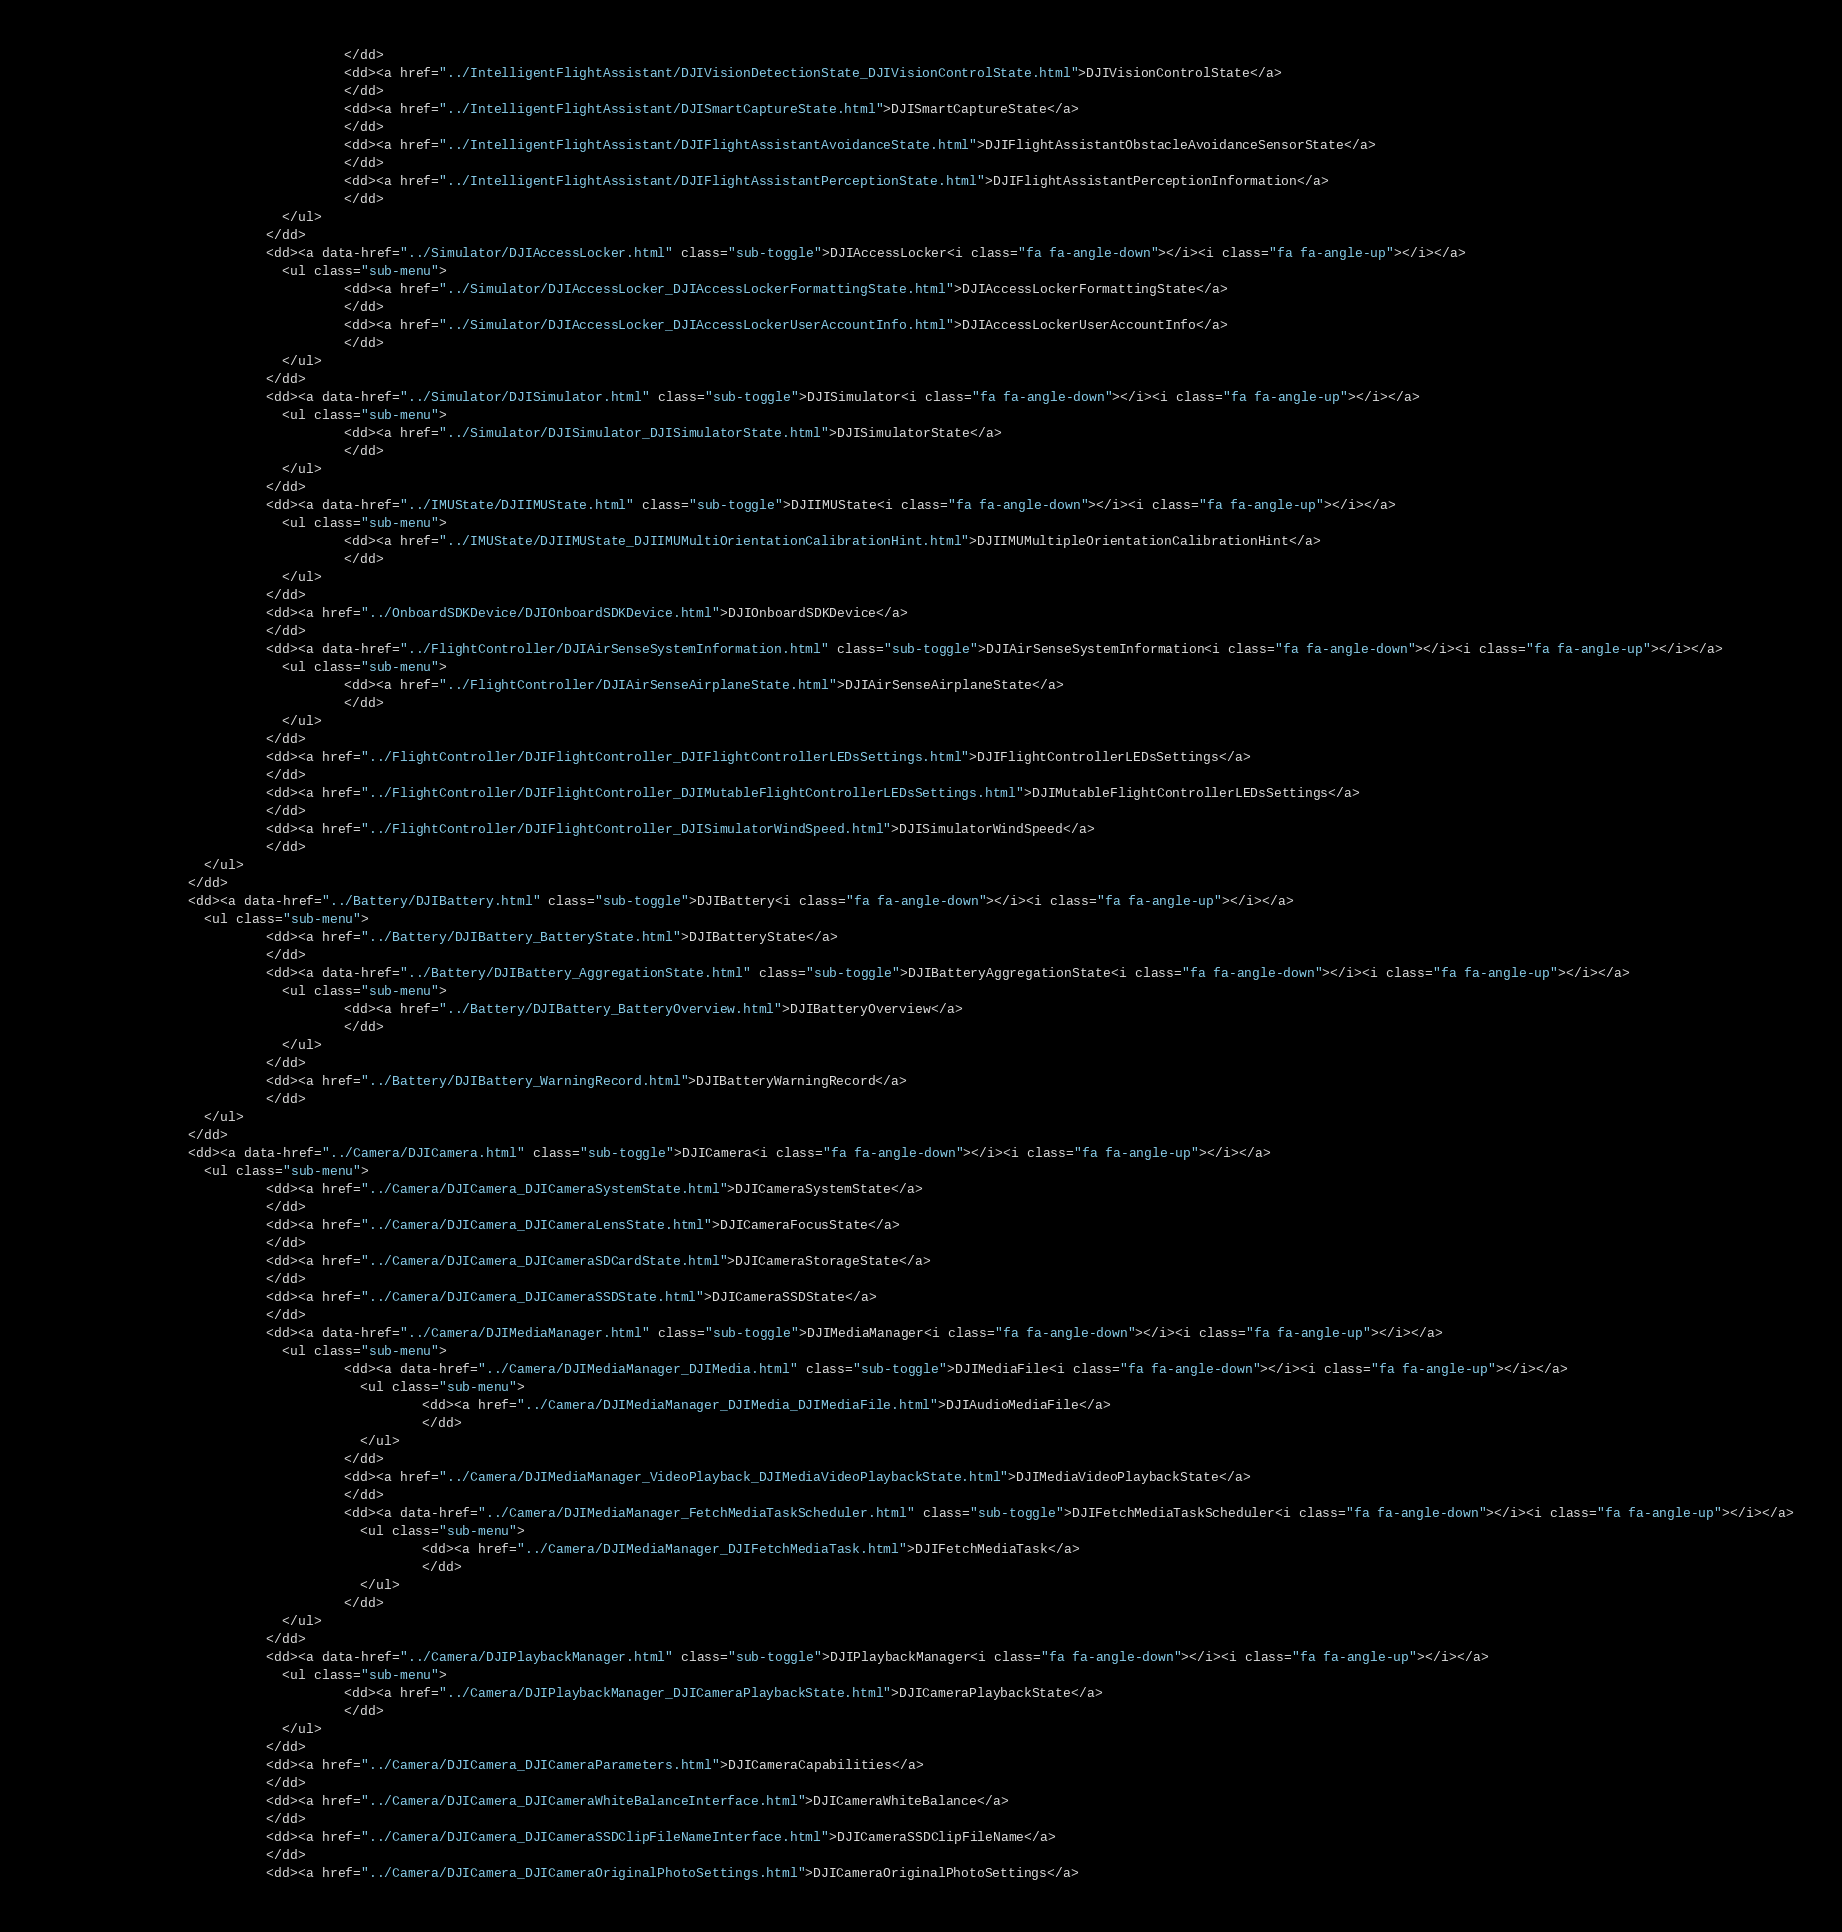<code> <loc_0><loc_0><loc_500><loc_500><_HTML_>                                      </dd>
                                      <dd><a href="../IntelligentFlightAssistant/DJIVisionDetectionState_DJIVisionControlState.html">DJIVisionControlState</a>
                                      </dd>
                                      <dd><a href="../IntelligentFlightAssistant/DJISmartCaptureState.html">DJISmartCaptureState</a>
                                      </dd>
                                      <dd><a href="../IntelligentFlightAssistant/DJIFlightAssistantAvoidanceState.html">DJIFlightAssistantObstacleAvoidanceSensorState</a>
                                      </dd>
                                      <dd><a href="../IntelligentFlightAssistant/DJIFlightAssistantPerceptionState.html">DJIFlightAssistantPerceptionInformation</a>
                                      </dd>
                              </ul>
                            </dd>
                            <dd><a data-href="../Simulator/DJIAccessLocker.html" class="sub-toggle">DJIAccessLocker<i class="fa fa-angle-down"></i><i class="fa fa-angle-up"></i></a>
                              <ul class="sub-menu">
                                      <dd><a href="../Simulator/DJIAccessLocker_DJIAccessLockerFormattingState.html">DJIAccessLockerFormattingState</a>
                                      </dd>
                                      <dd><a href="../Simulator/DJIAccessLocker_DJIAccessLockerUserAccountInfo.html">DJIAccessLockerUserAccountInfo</a>
                                      </dd>
                              </ul>
                            </dd>
                            <dd><a data-href="../Simulator/DJISimulator.html" class="sub-toggle">DJISimulator<i class="fa fa-angle-down"></i><i class="fa fa-angle-up"></i></a>
                              <ul class="sub-menu">
                                      <dd><a href="../Simulator/DJISimulator_DJISimulatorState.html">DJISimulatorState</a>
                                      </dd>
                              </ul>
                            </dd>
                            <dd><a data-href="../IMUState/DJIIMUState.html" class="sub-toggle">DJIIMUState<i class="fa fa-angle-down"></i><i class="fa fa-angle-up"></i></a>
                              <ul class="sub-menu">
                                      <dd><a href="../IMUState/DJIIMUState_DJIIMUMultiOrientationCalibrationHint.html">DJIIMUMultipleOrientationCalibrationHint</a>
                                      </dd>
                              </ul>
                            </dd>
                            <dd><a href="../OnboardSDKDevice/DJIOnboardSDKDevice.html">DJIOnboardSDKDevice</a>
                            </dd>
                            <dd><a data-href="../FlightController/DJIAirSenseSystemInformation.html" class="sub-toggle">DJIAirSenseSystemInformation<i class="fa fa-angle-down"></i><i class="fa fa-angle-up"></i></a>
                              <ul class="sub-menu">
                                      <dd><a href="../FlightController/DJIAirSenseAirplaneState.html">DJIAirSenseAirplaneState</a>
                                      </dd>
                              </ul>
                            </dd>
                            <dd><a href="../FlightController/DJIFlightController_DJIFlightControllerLEDsSettings.html">DJIFlightControllerLEDsSettings</a>
                            </dd>
                            <dd><a href="../FlightController/DJIFlightController_DJIMutableFlightControllerLEDsSettings.html">DJIMutableFlightControllerLEDsSettings</a>
                            </dd>
                            <dd><a href="../FlightController/DJIFlightController_DJISimulatorWindSpeed.html">DJISimulatorWindSpeed</a>
                            </dd>
                    </ul>
                  </dd>
                  <dd><a data-href="../Battery/DJIBattery.html" class="sub-toggle">DJIBattery<i class="fa fa-angle-down"></i><i class="fa fa-angle-up"></i></a>
                    <ul class="sub-menu">
                            <dd><a href="../Battery/DJIBattery_BatteryState.html">DJIBatteryState</a>
                            </dd>
                            <dd><a data-href="../Battery/DJIBattery_AggregationState.html" class="sub-toggle">DJIBatteryAggregationState<i class="fa fa-angle-down"></i><i class="fa fa-angle-up"></i></a>
                              <ul class="sub-menu">
                                      <dd><a href="../Battery/DJIBattery_BatteryOverview.html">DJIBatteryOverview</a>
                                      </dd>
                              </ul>
                            </dd>
                            <dd><a href="../Battery/DJIBattery_WarningRecord.html">DJIBatteryWarningRecord</a>
                            </dd>
                    </ul>
                  </dd>
                  <dd><a data-href="../Camera/DJICamera.html" class="sub-toggle">DJICamera<i class="fa fa-angle-down"></i><i class="fa fa-angle-up"></i></a>
                    <ul class="sub-menu">
                            <dd><a href="../Camera/DJICamera_DJICameraSystemState.html">DJICameraSystemState</a>
                            </dd>
                            <dd><a href="../Camera/DJICamera_DJICameraLensState.html">DJICameraFocusState</a>
                            </dd>
                            <dd><a href="../Camera/DJICamera_DJICameraSDCardState.html">DJICameraStorageState</a>
                            </dd>
                            <dd><a href="../Camera/DJICamera_DJICameraSSDState.html">DJICameraSSDState</a>
                            </dd>
                            <dd><a data-href="../Camera/DJIMediaManager.html" class="sub-toggle">DJIMediaManager<i class="fa fa-angle-down"></i><i class="fa fa-angle-up"></i></a>
                              <ul class="sub-menu">
                                      <dd><a data-href="../Camera/DJIMediaManager_DJIMedia.html" class="sub-toggle">DJIMediaFile<i class="fa fa-angle-down"></i><i class="fa fa-angle-up"></i></a>
                                        <ul class="sub-menu">
                                                <dd><a href="../Camera/DJIMediaManager_DJIMedia_DJIMediaFile.html">DJIAudioMediaFile</a>
                                                </dd>
                                        </ul>
                                      </dd>
                                      <dd><a href="../Camera/DJIMediaManager_VideoPlayback_DJIMediaVideoPlaybackState.html">DJIMediaVideoPlaybackState</a>
                                      </dd>
                                      <dd><a data-href="../Camera/DJIMediaManager_FetchMediaTaskScheduler.html" class="sub-toggle">DJIFetchMediaTaskScheduler<i class="fa fa-angle-down"></i><i class="fa fa-angle-up"></i></a>
                                        <ul class="sub-menu">
                                                <dd><a href="../Camera/DJIMediaManager_DJIFetchMediaTask.html">DJIFetchMediaTask</a>
                                                </dd>
                                        </ul>
                                      </dd>
                              </ul>
                            </dd>
                            <dd><a data-href="../Camera/DJIPlaybackManager.html" class="sub-toggle">DJIPlaybackManager<i class="fa fa-angle-down"></i><i class="fa fa-angle-up"></i></a>
                              <ul class="sub-menu">
                                      <dd><a href="../Camera/DJIPlaybackManager_DJICameraPlaybackState.html">DJICameraPlaybackState</a>
                                      </dd>
                              </ul>
                            </dd>
                            <dd><a href="../Camera/DJICamera_DJICameraParameters.html">DJICameraCapabilities</a>
                            </dd>
                            <dd><a href="../Camera/DJICamera_DJICameraWhiteBalanceInterface.html">DJICameraWhiteBalance</a>
                            </dd>
                            <dd><a href="../Camera/DJICamera_DJICameraSSDClipFileNameInterface.html">DJICameraSSDClipFileName</a>
                            </dd>
                            <dd><a href="../Camera/DJICamera_DJICameraOriginalPhotoSettings.html">DJICameraOriginalPhotoSettings</a></code> 